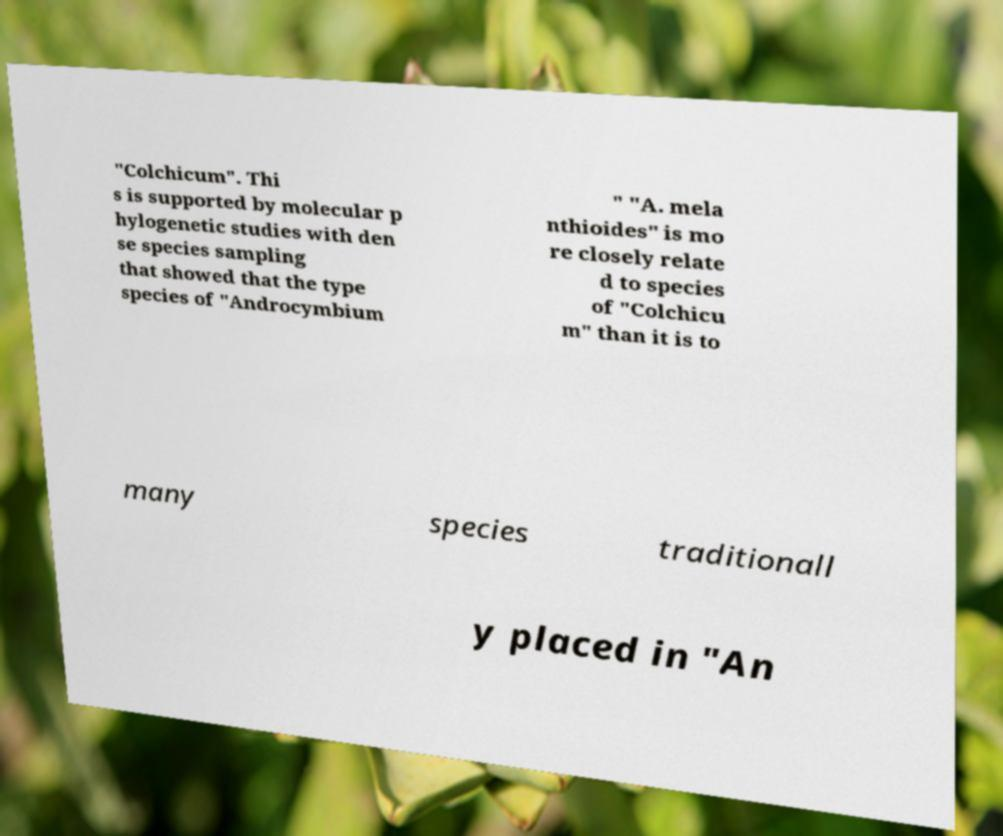Could you assist in decoding the text presented in this image and type it out clearly? "Colchicum". Thi s is supported by molecular p hylogenetic studies with den se species sampling that showed that the type species of "Androcymbium " "A. mela nthioides" is mo re closely relate d to species of "Colchicu m" than it is to many species traditionall y placed in "An 